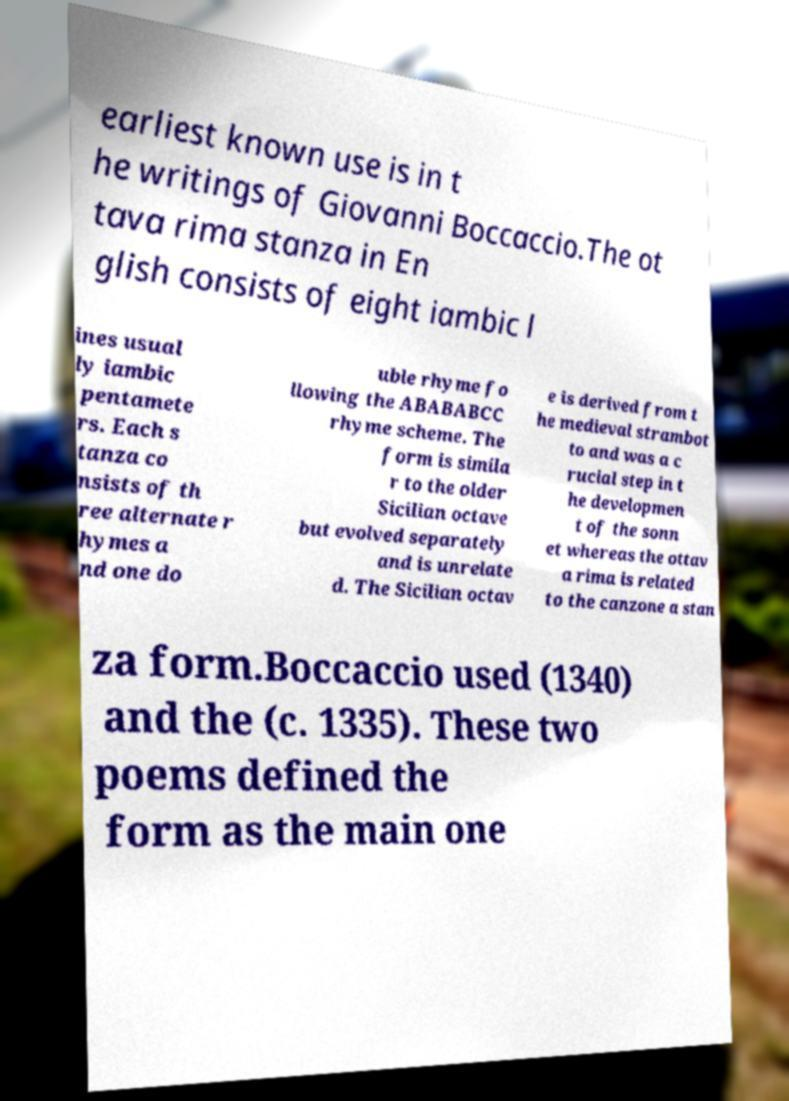Could you extract and type out the text from this image? earliest known use is in t he writings of Giovanni Boccaccio.The ot tava rima stanza in En glish consists of eight iambic l ines usual ly iambic pentamete rs. Each s tanza co nsists of th ree alternate r hymes a nd one do uble rhyme fo llowing the ABABABCC rhyme scheme. The form is simila r to the older Sicilian octave but evolved separately and is unrelate d. The Sicilian octav e is derived from t he medieval strambot to and was a c rucial step in t he developmen t of the sonn et whereas the ottav a rima is related to the canzone a stan za form.Boccaccio used (1340) and the (c. 1335). These two poems defined the form as the main one 